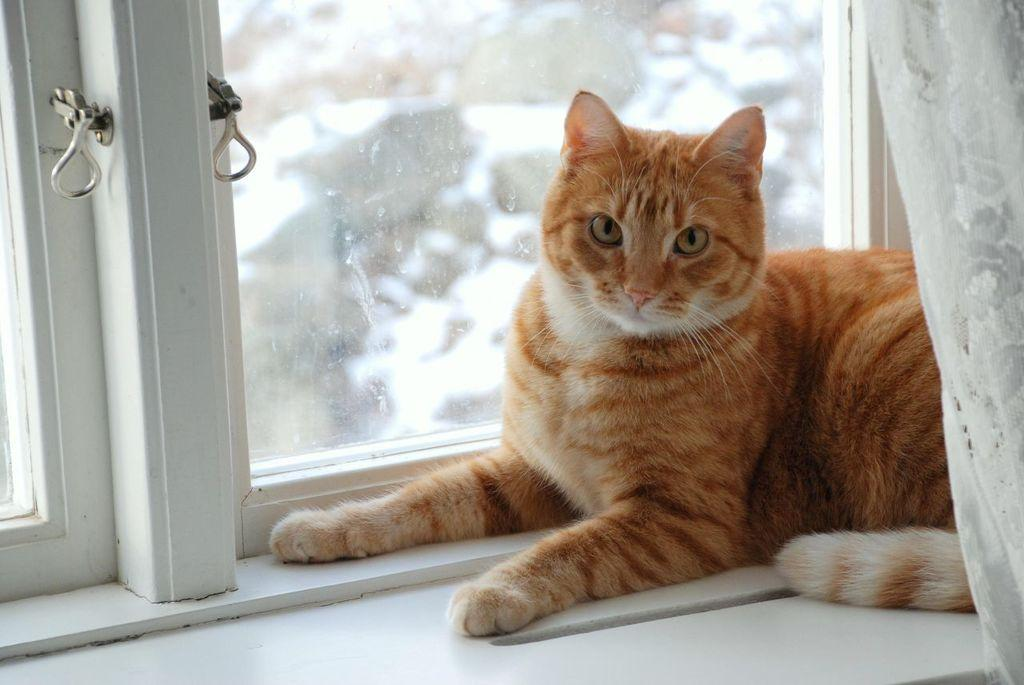What can be seen through the windows in the image? The facts provided do not give information about what can be seen through the windows. What type of curtain is present in the image? There is a white color curtain in the image. What animal is present in the image? There is a cat in the image. What type of rod is the minister holding in the image? There is no minister or rod present in the image. How many bottles can be seen in the image? There are no bottles present in the image. 